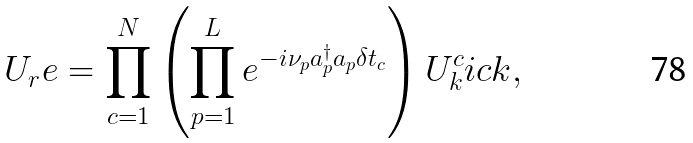<formula> <loc_0><loc_0><loc_500><loc_500>U _ { r } e = \prod _ { c = 1 } ^ { N } \left ( \prod _ { p = 1 } ^ { L } e ^ { - i \nu _ { p } a ^ { \dagger } _ { p } a _ { p } \delta t _ { c } } \right ) U ^ { c } _ { k } i c k ,</formula> 